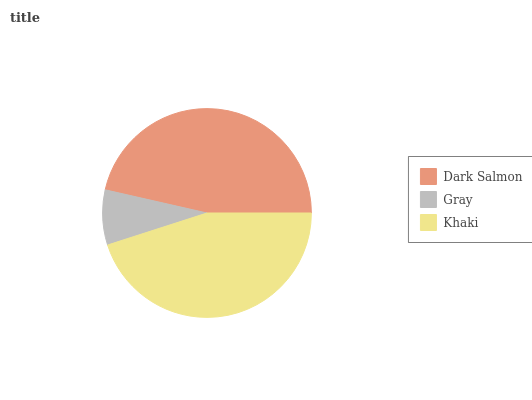Is Gray the minimum?
Answer yes or no. Yes. Is Dark Salmon the maximum?
Answer yes or no. Yes. Is Khaki the minimum?
Answer yes or no. No. Is Khaki the maximum?
Answer yes or no. No. Is Khaki greater than Gray?
Answer yes or no. Yes. Is Gray less than Khaki?
Answer yes or no. Yes. Is Gray greater than Khaki?
Answer yes or no. No. Is Khaki less than Gray?
Answer yes or no. No. Is Khaki the high median?
Answer yes or no. Yes. Is Khaki the low median?
Answer yes or no. Yes. Is Gray the high median?
Answer yes or no. No. Is Dark Salmon the low median?
Answer yes or no. No. 